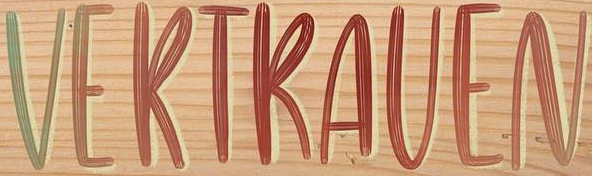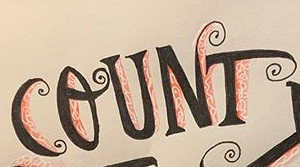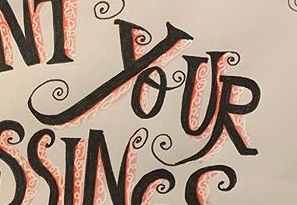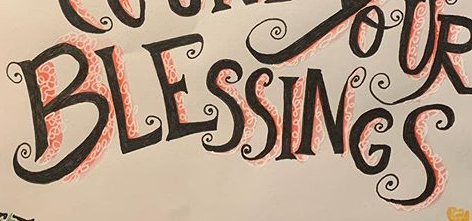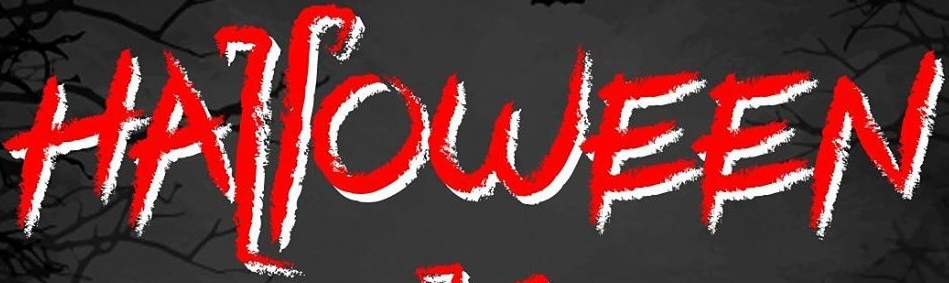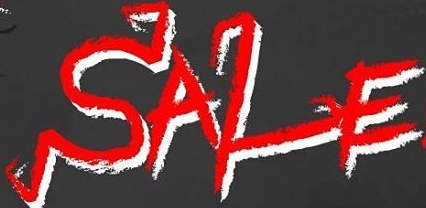What words are shown in these images in order, separated by a semicolon? VERTRAVEN; COUNT; YOUR; BLESSINGS; HALLOWEEN; SALE 